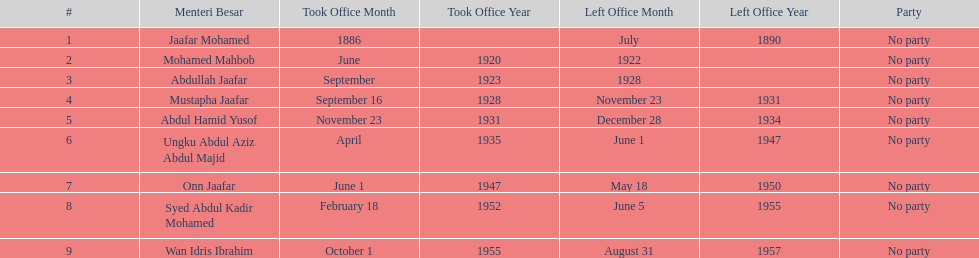Can you parse all the data within this table? {'header': ['#', 'Menteri Besar', 'Took Office Month', 'Took Office Year', 'Left Office Month', 'Left Office Year', 'Party'], 'rows': [['1', 'Jaafar Mohamed', '1886', '', 'July', '1890', 'No party'], ['2', 'Mohamed Mahbob', 'June', '1920', '1922', '', 'No party'], ['3', 'Abdullah Jaafar', 'September', '1923', '1928', '', 'No party'], ['4', 'Mustapha Jaafar', 'September 16', '1928', 'November 23', '1931', 'No party'], ['5', 'Abdul Hamid Yusof', 'November 23', '1931', 'December 28', '1934', 'No party'], ['6', 'Ungku Abdul Aziz Abdul Majid', 'April', '1935', 'June 1', '1947', 'No party'], ['7', 'Onn Jaafar', 'June 1', '1947', 'May 18', '1950', 'No party'], ['8', 'Syed Abdul Kadir Mohamed', 'February 18', '1952', 'June 5', '1955', 'No party'], ['9', 'Wan Idris Ibrahim', 'October 1', '1955', 'August 31', '1957', 'No party']]} What was the date the last person on the list left office? August 31, 1957. 